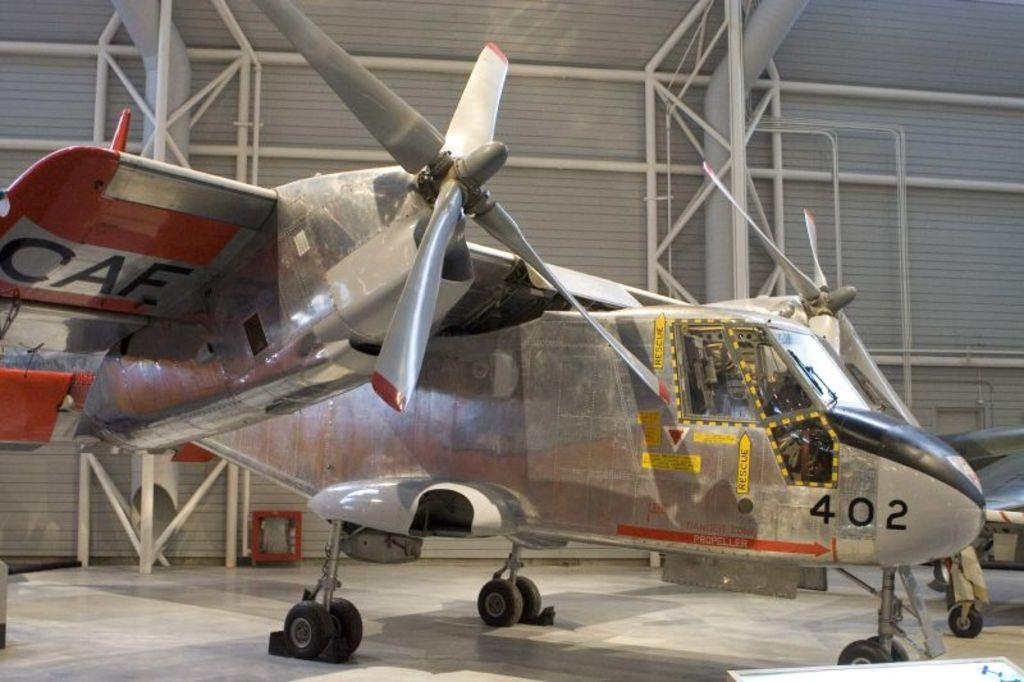<image>
Provide a brief description of the given image. Small Airplane in a hanger with the number model 402. 